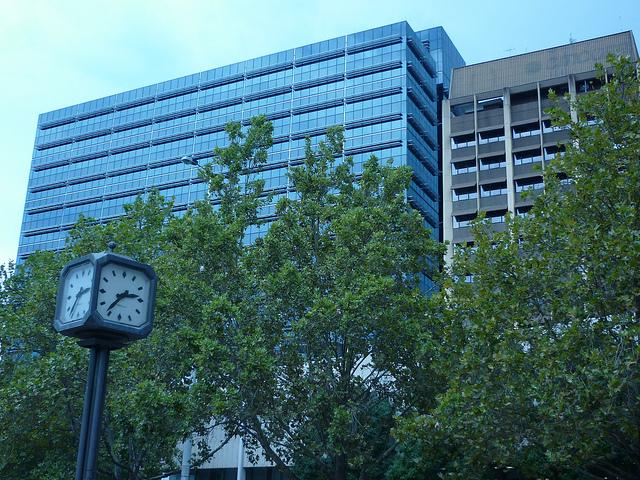How many windows in the shot?
Be succinct. Hundreds. What time is it?
Be succinct. 2:36. What is the light attached to?
Quick response, please. Pole. How many clock faces are shown?
Answer briefly. 2. 